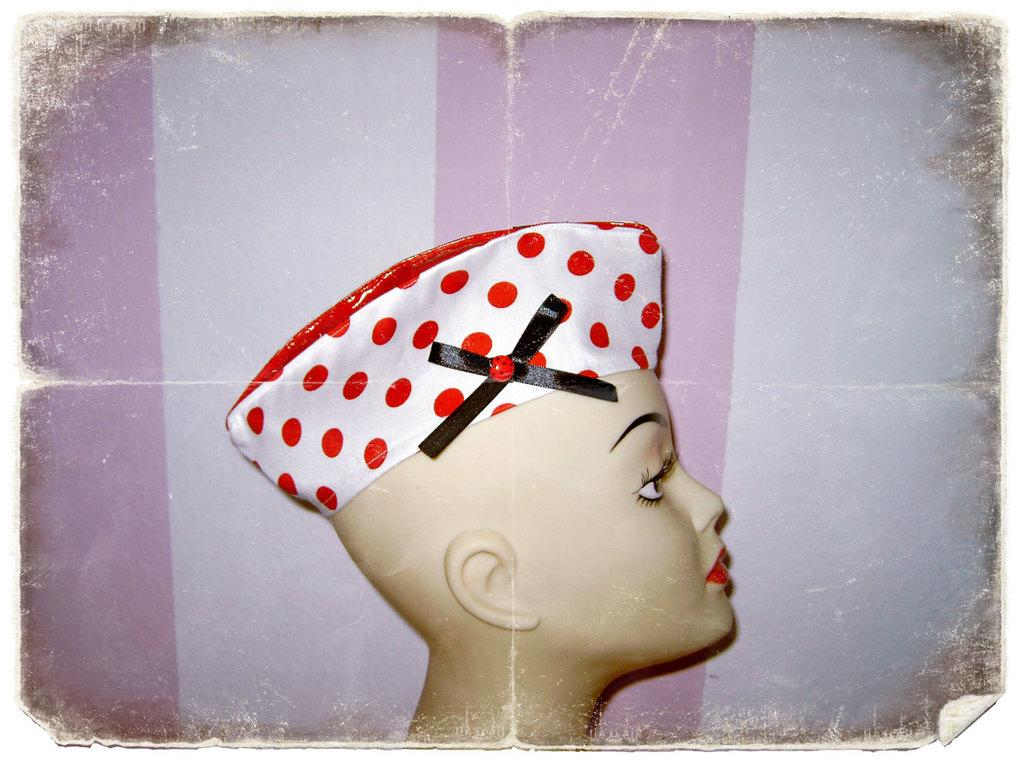What is the main subject of the image? There is a depiction of a person's face in the image. Can you describe any specific features of the face? Unfortunately, the provided facts do not include any specific details about the face. What might the person's face be used for in the image? The purpose of the person's face in the image cannot be determined from the given facts. What type of test is being conducted on the person's face in the image? There is no indication of a test being conducted on the person's face in the image. 